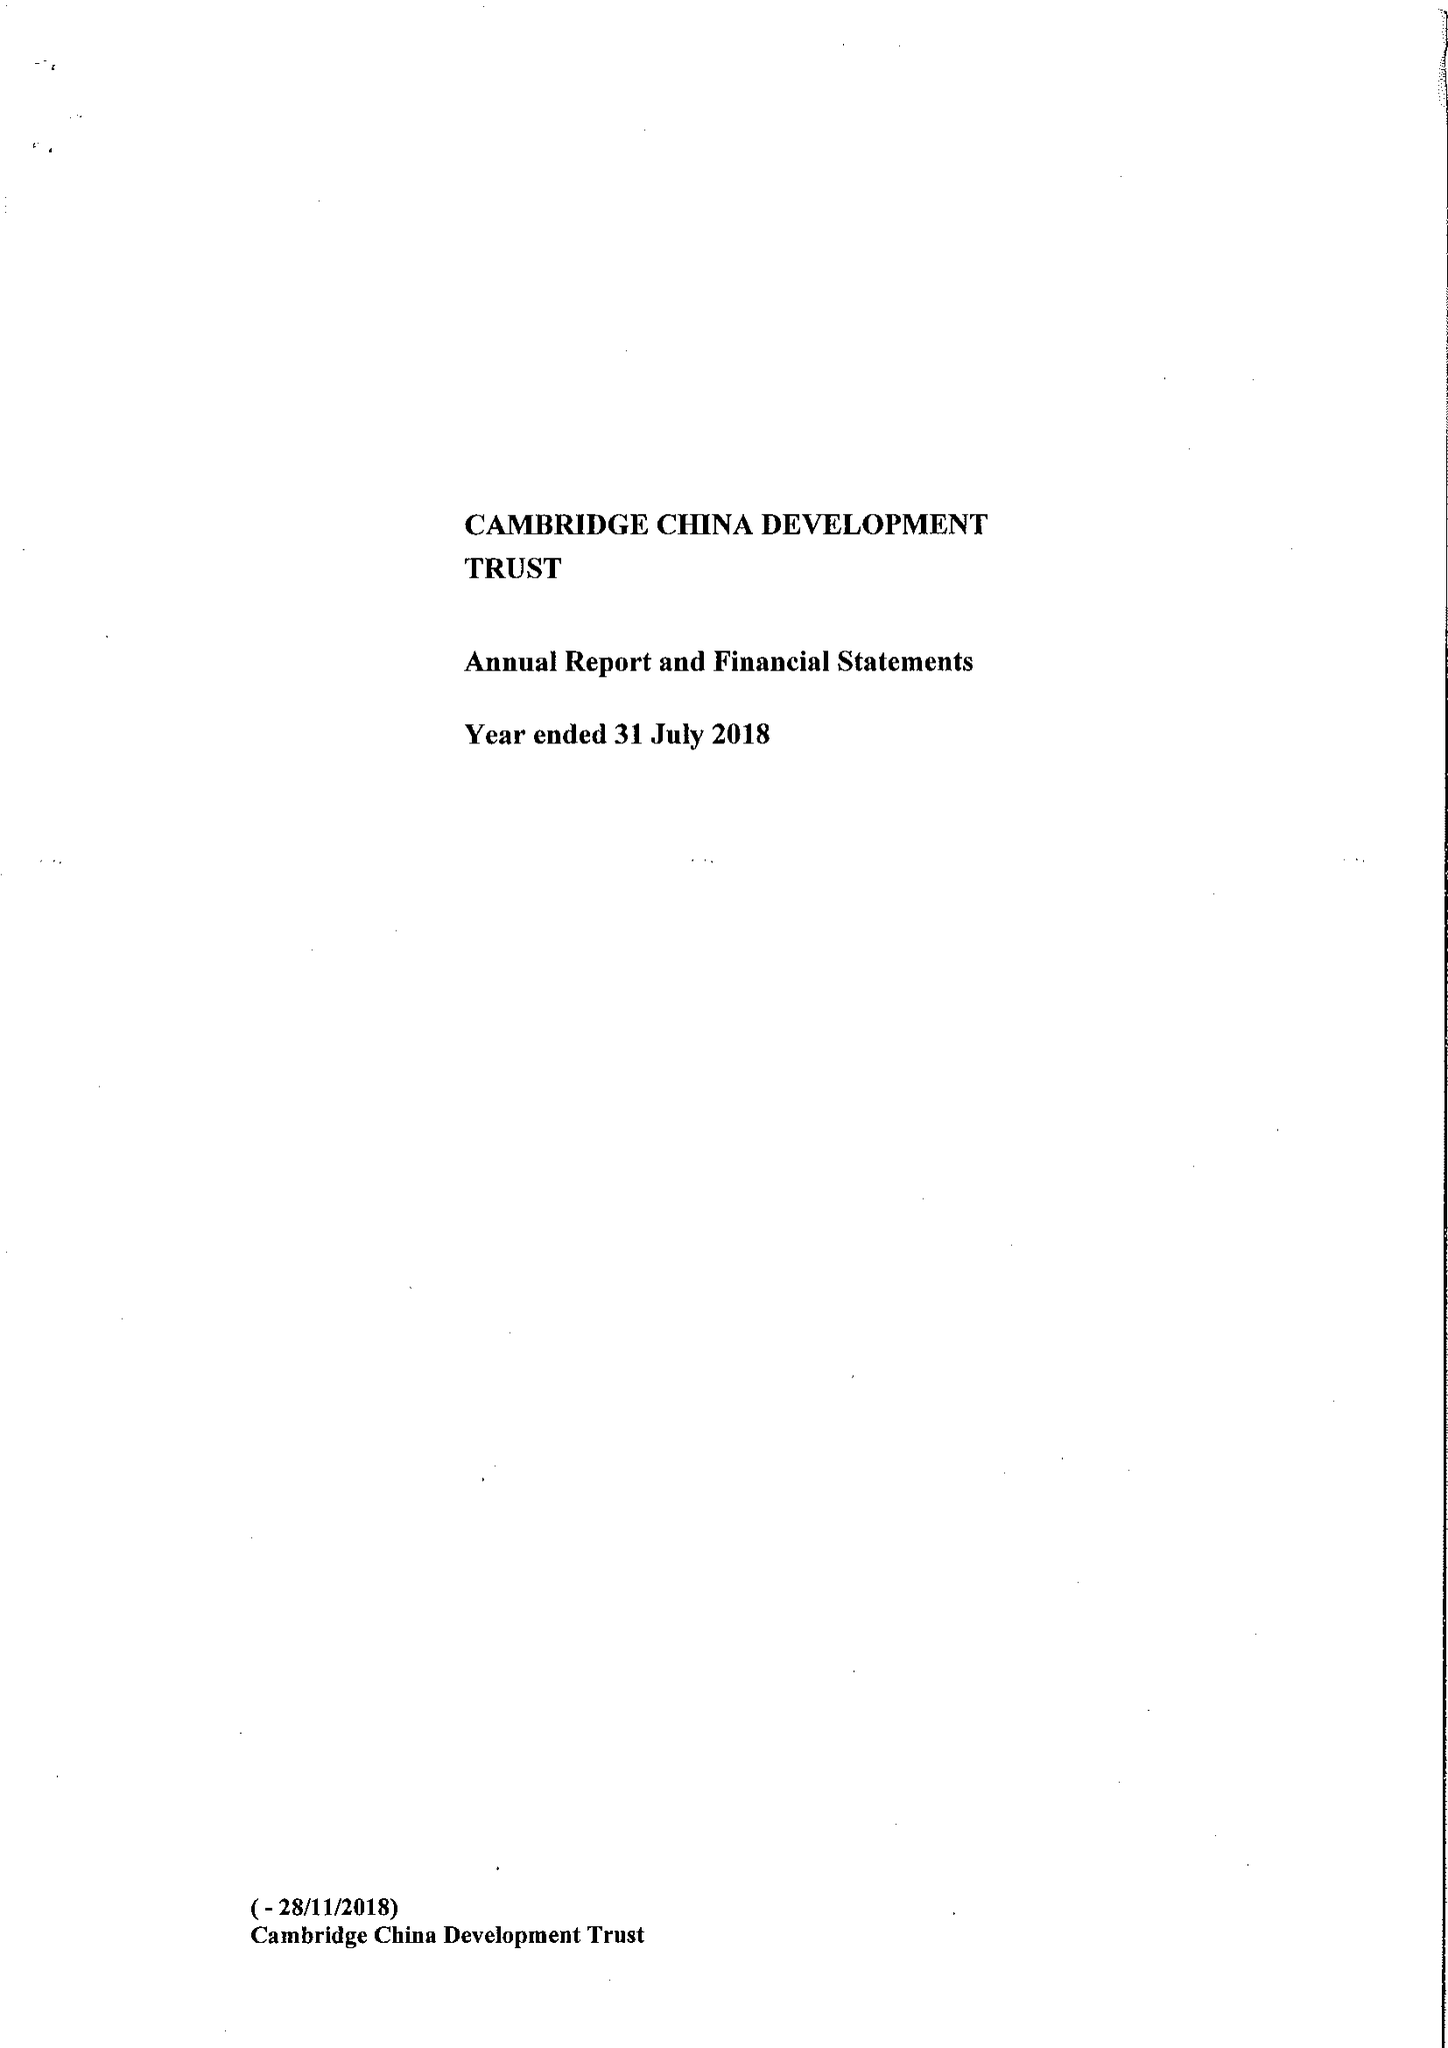What is the value for the address__postcode?
Answer the question using a single word or phrase. CB2 1TQ 